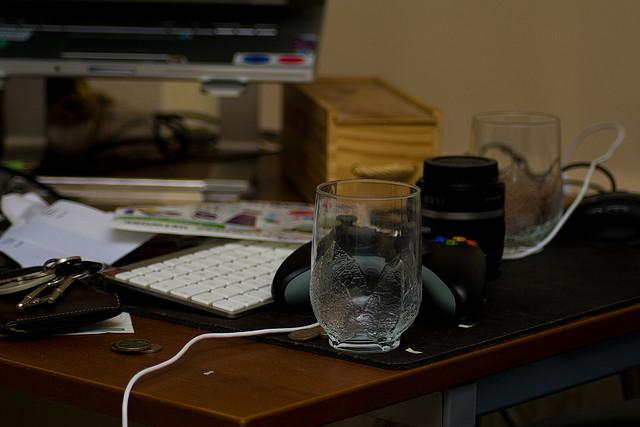What are most keys made of? metal 